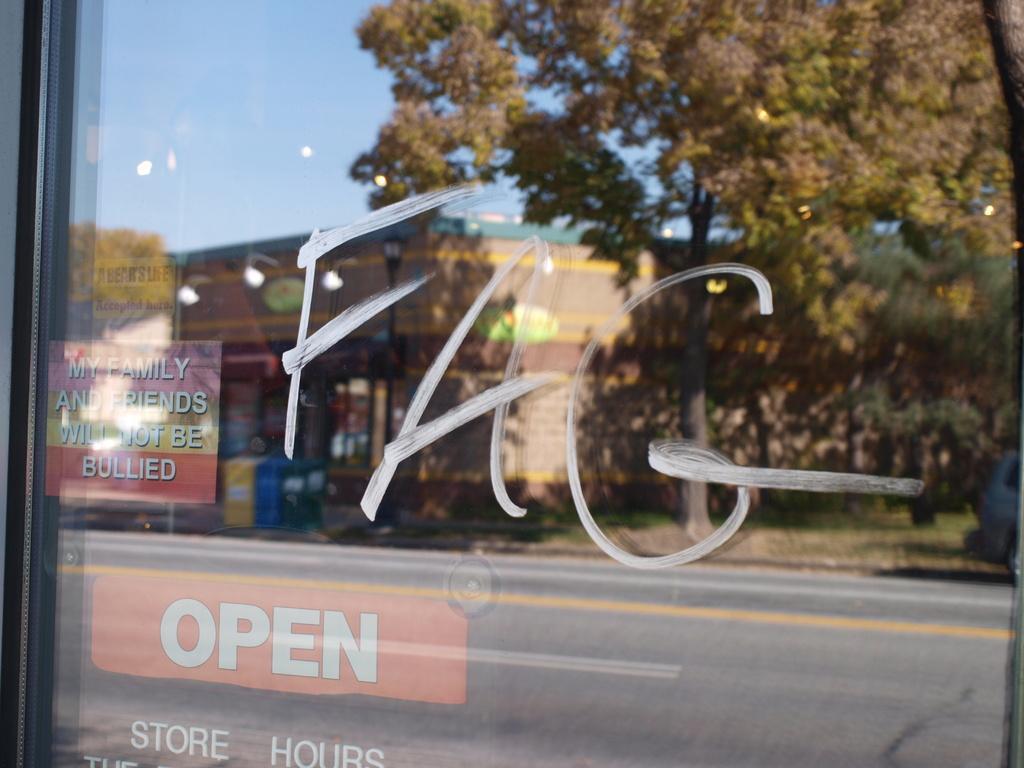In one or two sentences, can you explain what this image depicts? In this image I can see the glass surface and on it I can see the reflection of few trees, few buildings, the road and the sky. 